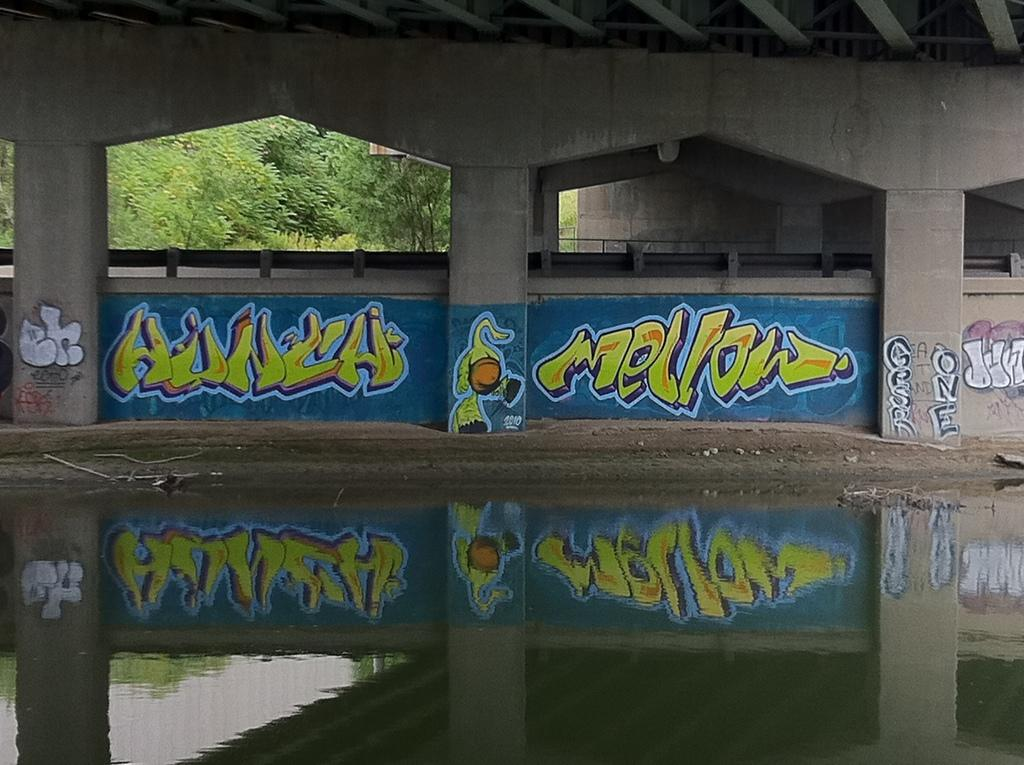What type of artwork is depicted in the image? The image is a painting. What type of building can be seen in the painting? There is an arc building in the painting. What natural elements are present in the painting? There is water and sand in the painting. What type of vegetation is in the painting? There are trees in the painting. How does the fog affect the visibility of the arc building in the painting? There is no fog present in the painting; it only features an arc building, water, sand, and trees. 